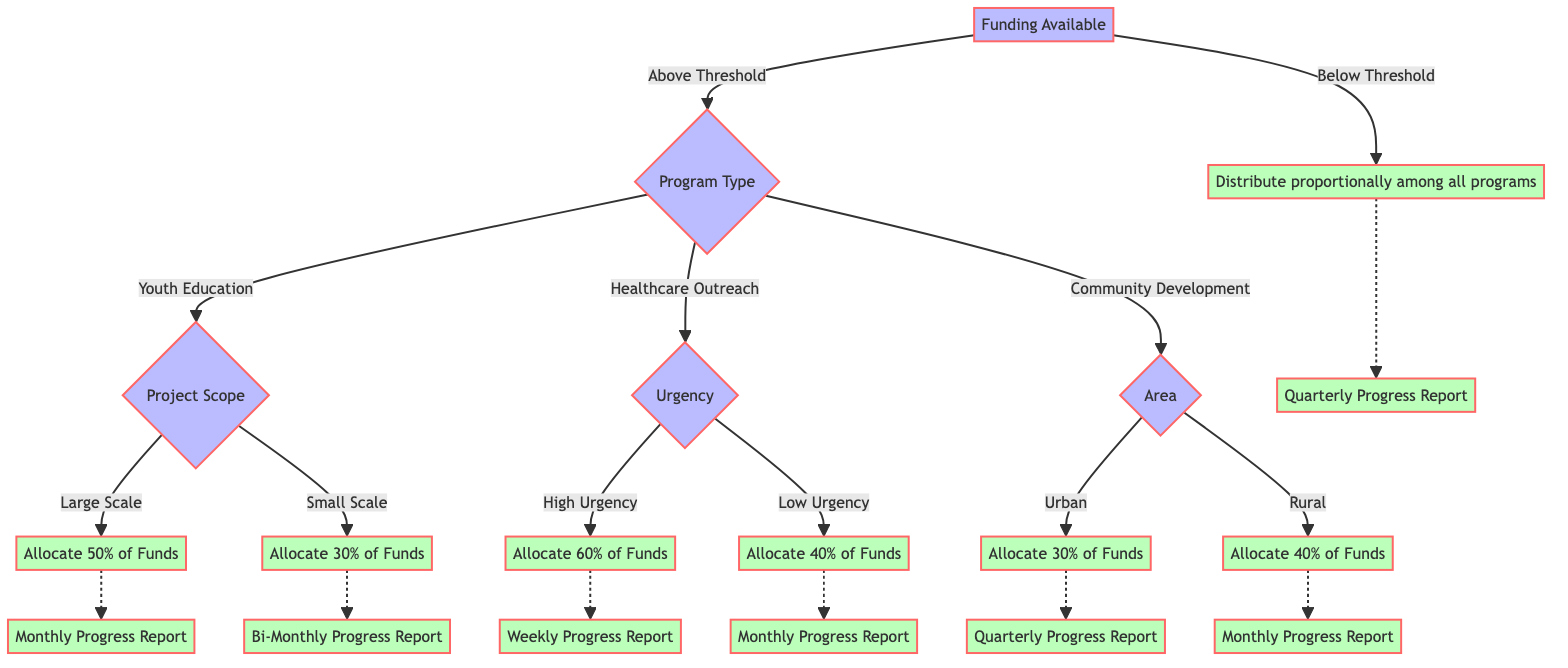What happens if the funding is below threshold? If the funding is below threshold, the diagram indicates that funds will be distributed proportionally among all programs. This follows the path that leads from the root node to the "Below Threshold" node, where the allocation method is specified.
Answer: Distribute proportionally among all programs What is the follow-up for Youth Education projects with a Large Scale? The diagram shows that the follow-up for Youth Education projects classified as Large Scale is a Monthly Progress Report. This follow-up is specifically indicated as the outcome of the "C" node (Project Scope) when the decision is Large Scale.
Answer: Monthly Progress Report How much of the funds are allocated for Healthcare Outreach with Low Urgency? The allocation for Healthcare Outreach with Low Urgency is 40% of funds. This is derived from the decision tree path leading through the "Healthcare Outreach" node to the "Low Urgency" node.
Answer: 40% of Funds What is the followup for the Community Development in Urban areas? According to the diagram, the follow-up for Community Development projects in Urban areas is a Quarterly Progress Report. This can be traced from the Community Development node to the Urban area decision.
Answer: Quarterly Progress Report Which program type receives the highest percentage of funds when the urgency is high? The program type that receives the highest percentage of funds with High Urgency is Healthcare Outreach, which is allocated 60% of funds, as outlined in the "Urgency" decision node of the Healthcare Outreach branch.
Answer: 60% of Funds What is the allocation for Small Scale Youth Education projects? The allocation for Small Scale Youth Education projects is clearly stated as 30% of funds in the decision tree. This can be seen directly from the "Small Scale" node under the "Youth Education" criteria.
Answer: 30% of Funds How many follow-up types are there for Community Development? There are two follow-up types for Community Development, which are Quarterly Progress Report for Urban areas and Monthly Progress Report for Rural areas. This can be verified by looking at the "Area" node under Community Development.
Answer: Two types What do you need to determine before moving from the root node? Before moving from the root node, you need to determine if the Funding Available is Above Threshold or Below Threshold. This decision directly influences the path taken in the decision tree.
Answer: Above Threshold or Below Threshold 